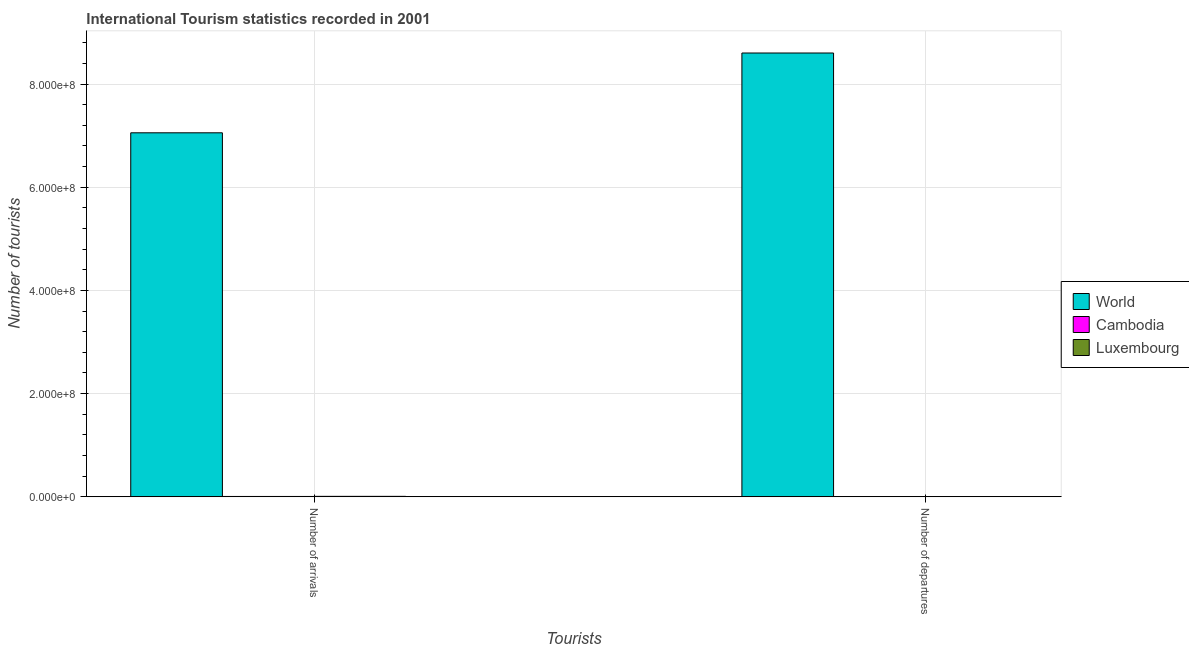How many bars are there on the 1st tick from the right?
Offer a very short reply. 3. What is the label of the 1st group of bars from the left?
Your answer should be very brief. Number of arrivals. What is the number of tourist departures in World?
Make the answer very short. 8.60e+08. Across all countries, what is the maximum number of tourist arrivals?
Your answer should be very brief. 7.06e+08. Across all countries, what is the minimum number of tourist arrivals?
Give a very brief answer. 6.05e+05. In which country was the number of tourist arrivals maximum?
Keep it short and to the point. World. In which country was the number of tourist departures minimum?
Your answer should be compact. Cambodia. What is the total number of tourist departures in the graph?
Your answer should be very brief. 8.60e+08. What is the difference between the number of tourist arrivals in Cambodia and that in World?
Your answer should be compact. -7.05e+08. What is the difference between the number of tourist departures in Cambodia and the number of tourist arrivals in World?
Provide a short and direct response. -7.05e+08. What is the average number of tourist arrivals per country?
Your response must be concise. 2.36e+08. What is the difference between the number of tourist arrivals and number of tourist departures in Cambodia?
Ensure brevity in your answer.  5.68e+05. What is the ratio of the number of tourist departures in World to that in Cambodia?
Give a very brief answer. 2.32e+04. Is the number of tourist arrivals in World less than that in Luxembourg?
Provide a short and direct response. No. What does the 3rd bar from the left in Number of departures represents?
Provide a succinct answer. Luxembourg. What does the 2nd bar from the right in Number of departures represents?
Ensure brevity in your answer.  Cambodia. Are all the bars in the graph horizontal?
Provide a short and direct response. No. Are the values on the major ticks of Y-axis written in scientific E-notation?
Make the answer very short. Yes. Does the graph contain grids?
Your answer should be very brief. Yes. How are the legend labels stacked?
Make the answer very short. Vertical. What is the title of the graph?
Give a very brief answer. International Tourism statistics recorded in 2001. What is the label or title of the X-axis?
Ensure brevity in your answer.  Tourists. What is the label or title of the Y-axis?
Your response must be concise. Number of tourists. What is the Number of tourists of World in Number of arrivals?
Provide a succinct answer. 7.06e+08. What is the Number of tourists of Cambodia in Number of arrivals?
Offer a terse response. 6.05e+05. What is the Number of tourists of Luxembourg in Number of arrivals?
Give a very brief answer. 8.36e+05. What is the Number of tourists of World in Number of departures?
Keep it short and to the point. 8.60e+08. What is the Number of tourists in Cambodia in Number of departures?
Offer a very short reply. 3.70e+04. What is the Number of tourists of Luxembourg in Number of departures?
Make the answer very short. 2.61e+05. Across all Tourists, what is the maximum Number of tourists in World?
Your answer should be very brief. 8.60e+08. Across all Tourists, what is the maximum Number of tourists of Cambodia?
Provide a short and direct response. 6.05e+05. Across all Tourists, what is the maximum Number of tourists of Luxembourg?
Provide a succinct answer. 8.36e+05. Across all Tourists, what is the minimum Number of tourists of World?
Provide a succinct answer. 7.06e+08. Across all Tourists, what is the minimum Number of tourists in Cambodia?
Make the answer very short. 3.70e+04. Across all Tourists, what is the minimum Number of tourists in Luxembourg?
Your answer should be compact. 2.61e+05. What is the total Number of tourists of World in the graph?
Your answer should be very brief. 1.57e+09. What is the total Number of tourists of Cambodia in the graph?
Keep it short and to the point. 6.42e+05. What is the total Number of tourists of Luxembourg in the graph?
Your answer should be very brief. 1.10e+06. What is the difference between the Number of tourists in World in Number of arrivals and that in Number of departures?
Your response must be concise. -1.55e+08. What is the difference between the Number of tourists in Cambodia in Number of arrivals and that in Number of departures?
Provide a short and direct response. 5.68e+05. What is the difference between the Number of tourists of Luxembourg in Number of arrivals and that in Number of departures?
Your answer should be compact. 5.75e+05. What is the difference between the Number of tourists in World in Number of arrivals and the Number of tourists in Cambodia in Number of departures?
Provide a succinct answer. 7.05e+08. What is the difference between the Number of tourists in World in Number of arrivals and the Number of tourists in Luxembourg in Number of departures?
Keep it short and to the point. 7.05e+08. What is the difference between the Number of tourists in Cambodia in Number of arrivals and the Number of tourists in Luxembourg in Number of departures?
Provide a succinct answer. 3.44e+05. What is the average Number of tourists in World per Tourists?
Ensure brevity in your answer.  7.83e+08. What is the average Number of tourists of Cambodia per Tourists?
Provide a short and direct response. 3.21e+05. What is the average Number of tourists of Luxembourg per Tourists?
Make the answer very short. 5.48e+05. What is the difference between the Number of tourists in World and Number of tourists in Cambodia in Number of arrivals?
Your response must be concise. 7.05e+08. What is the difference between the Number of tourists in World and Number of tourists in Luxembourg in Number of arrivals?
Ensure brevity in your answer.  7.05e+08. What is the difference between the Number of tourists in Cambodia and Number of tourists in Luxembourg in Number of arrivals?
Offer a very short reply. -2.31e+05. What is the difference between the Number of tourists of World and Number of tourists of Cambodia in Number of departures?
Provide a succinct answer. 8.60e+08. What is the difference between the Number of tourists of World and Number of tourists of Luxembourg in Number of departures?
Your answer should be compact. 8.60e+08. What is the difference between the Number of tourists in Cambodia and Number of tourists in Luxembourg in Number of departures?
Ensure brevity in your answer.  -2.24e+05. What is the ratio of the Number of tourists in World in Number of arrivals to that in Number of departures?
Your response must be concise. 0.82. What is the ratio of the Number of tourists of Cambodia in Number of arrivals to that in Number of departures?
Offer a terse response. 16.35. What is the ratio of the Number of tourists of Luxembourg in Number of arrivals to that in Number of departures?
Make the answer very short. 3.2. What is the difference between the highest and the second highest Number of tourists of World?
Your answer should be very brief. 1.55e+08. What is the difference between the highest and the second highest Number of tourists of Cambodia?
Give a very brief answer. 5.68e+05. What is the difference between the highest and the second highest Number of tourists of Luxembourg?
Offer a terse response. 5.75e+05. What is the difference between the highest and the lowest Number of tourists of World?
Provide a succinct answer. 1.55e+08. What is the difference between the highest and the lowest Number of tourists in Cambodia?
Your answer should be compact. 5.68e+05. What is the difference between the highest and the lowest Number of tourists in Luxembourg?
Your answer should be very brief. 5.75e+05. 